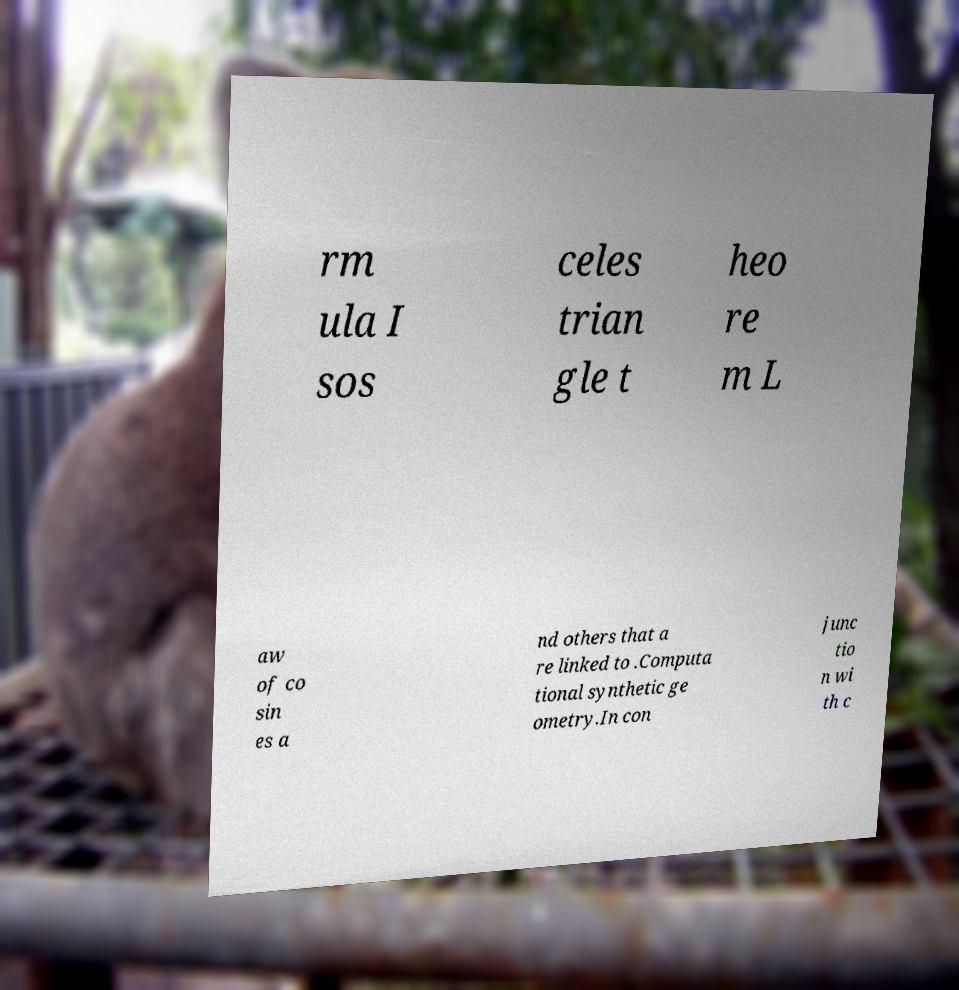For documentation purposes, I need the text within this image transcribed. Could you provide that? rm ula I sos celes trian gle t heo re m L aw of co sin es a nd others that a re linked to .Computa tional synthetic ge ometry.In con junc tio n wi th c 